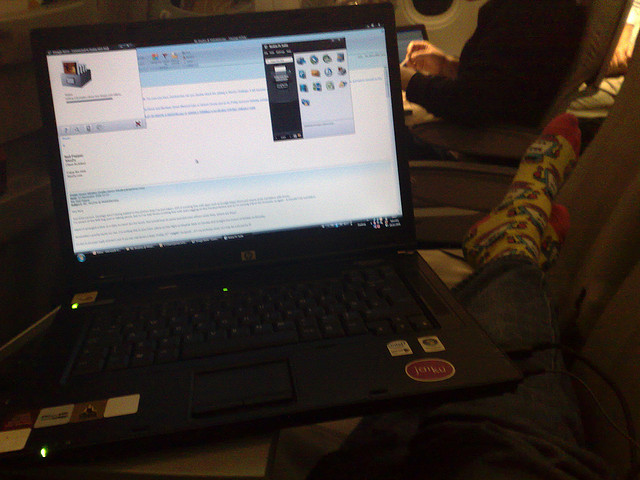How many speakers does the electronic device have? The laptop in the image has a common design which usually incorporates a pair of built-in speakers, typically located on the front edge or the sides of the keyboard. Therefore, it is likely that this device also has two speakers to provide stereo audio output. 